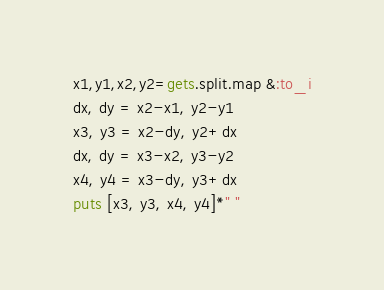<code> <loc_0><loc_0><loc_500><loc_500><_Ruby_>x1,y1,x2,y2=gets.split.map &:to_i
dx, dy = x2-x1, y2-y1
x3, y3 = x2-dy, y2+dx
dx, dy = x3-x2, y3-y2
x4, y4 = x3-dy, y3+dx
puts [x3, y3, x4, y4]*" "</code> 